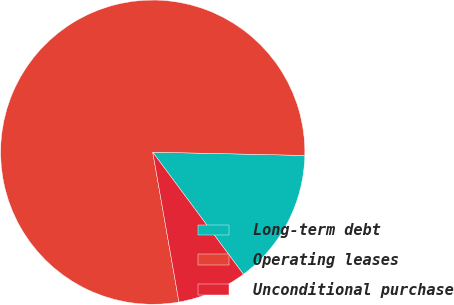Convert chart to OTSL. <chart><loc_0><loc_0><loc_500><loc_500><pie_chart><fcel>Long-term debt<fcel>Operating leases<fcel>Unconditional purchase<nl><fcel>14.49%<fcel>78.1%<fcel>7.41%<nl></chart> 